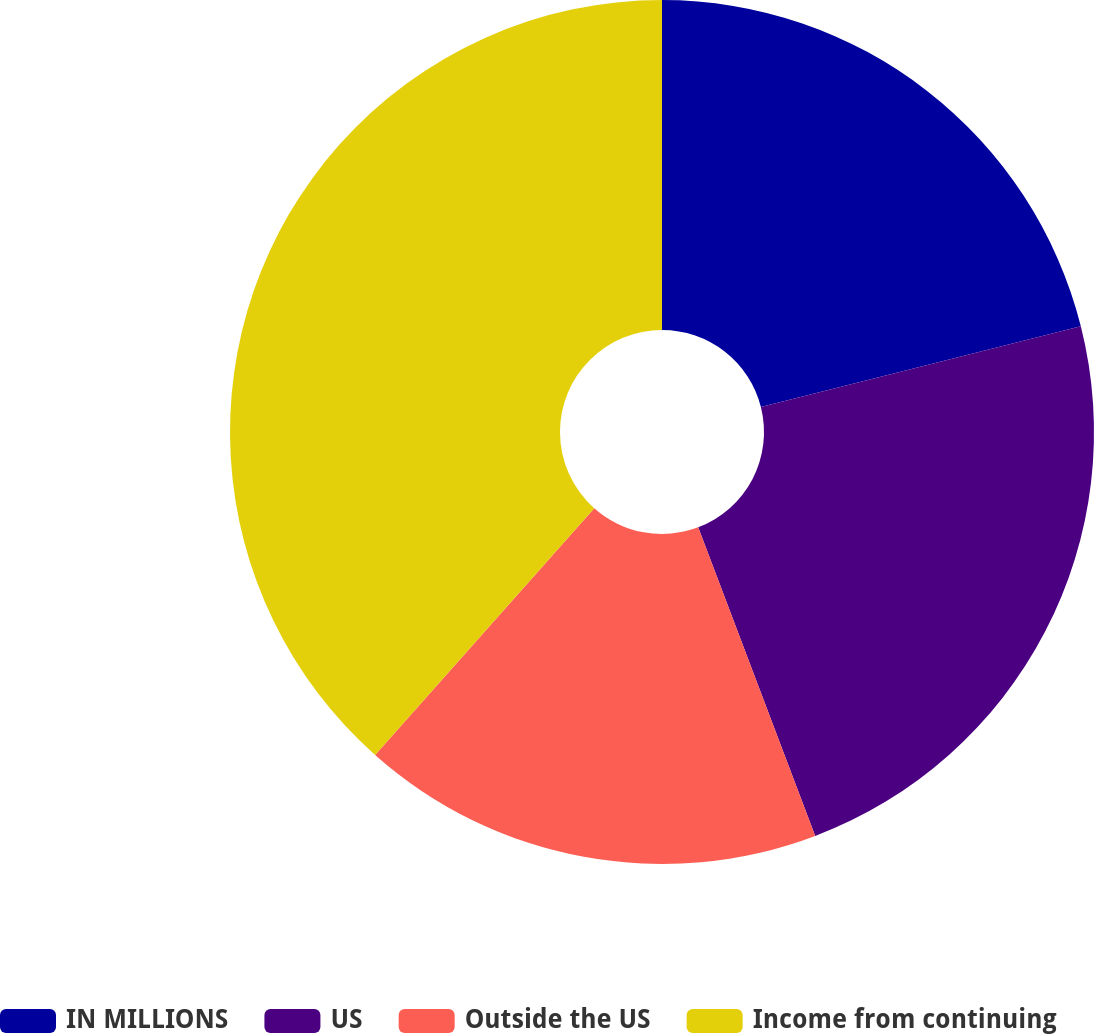Convert chart. <chart><loc_0><loc_0><loc_500><loc_500><pie_chart><fcel>IN MILLIONS<fcel>US<fcel>Outside the US<fcel>Income from continuing<nl><fcel>21.06%<fcel>23.17%<fcel>17.33%<fcel>38.44%<nl></chart> 